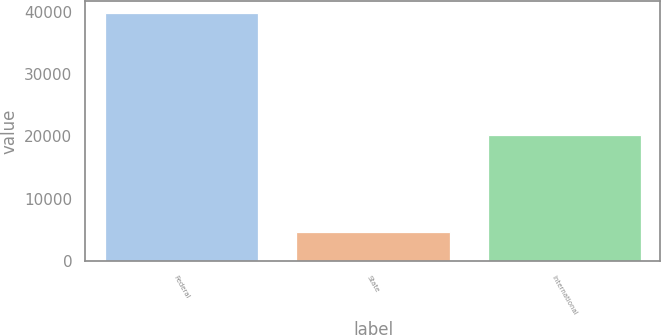Convert chart to OTSL. <chart><loc_0><loc_0><loc_500><loc_500><bar_chart><fcel>Federal<fcel>State<fcel>International<nl><fcel>39713<fcel>4692<fcel>20213<nl></chart> 